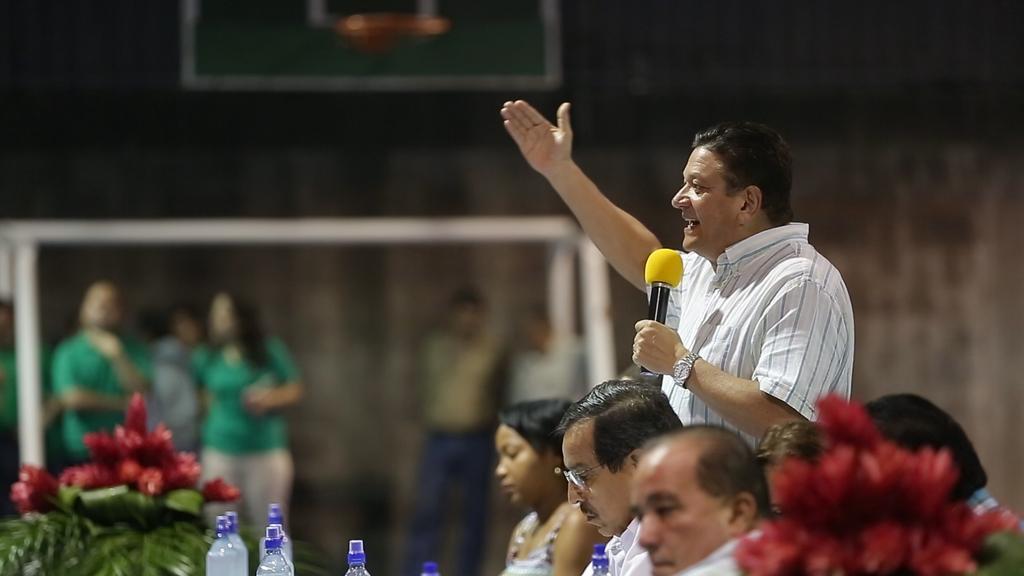Describe this image in one or two sentences. In this image we can see some group of persons sitting on chairs and there is a person wearing white color dress holding microphone in his hands and standing, on left side of the image there are some water bottles, flower bouquet and in the background of the image there are some persons standing. 